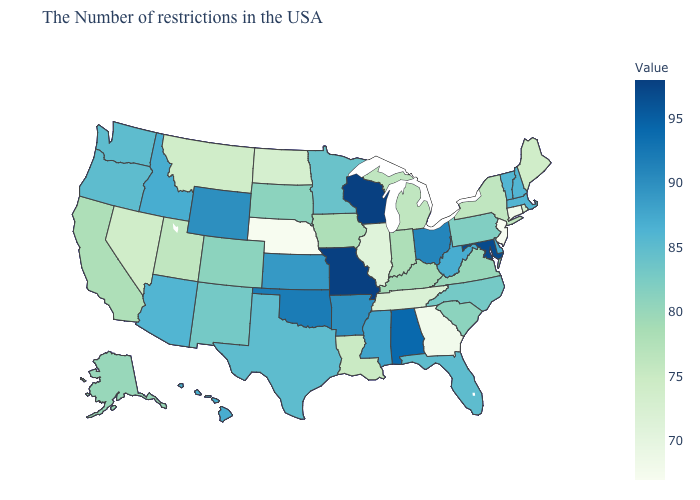Among the states that border Iowa , which have the lowest value?
Quick response, please. Nebraska. Is the legend a continuous bar?
Write a very short answer. Yes. Among the states that border Montana , which have the lowest value?
Write a very short answer. North Dakota. 